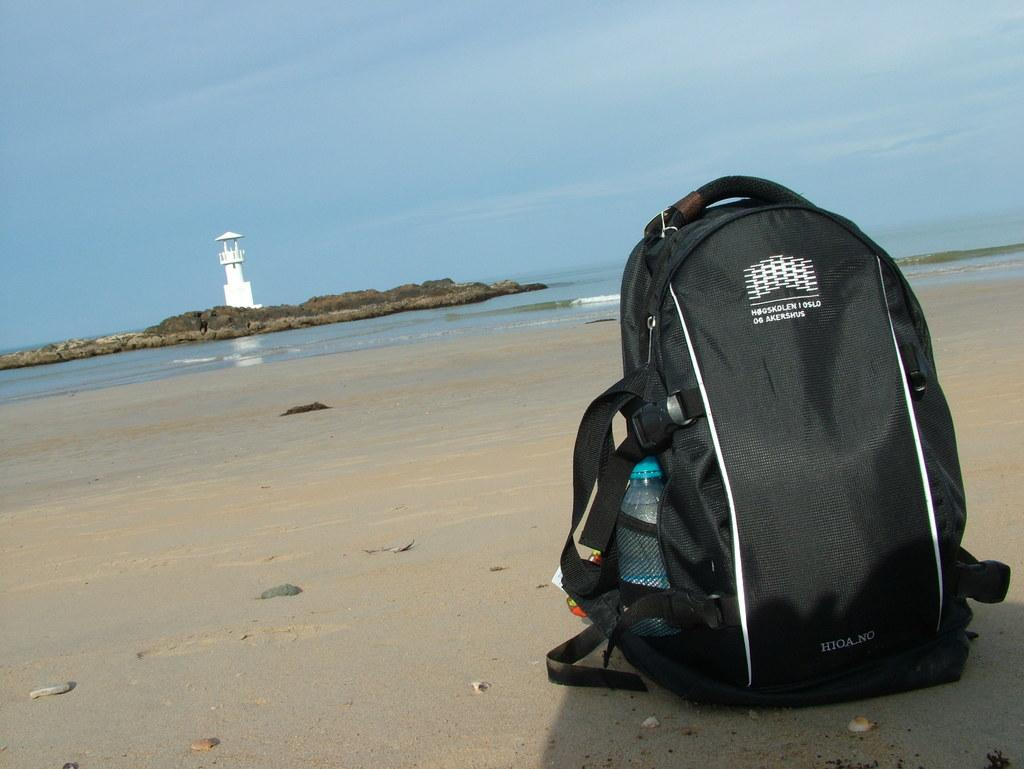<image>
Provide a brief description of the given image. A black backpack sitting on a beach has the word Oslo on it. 